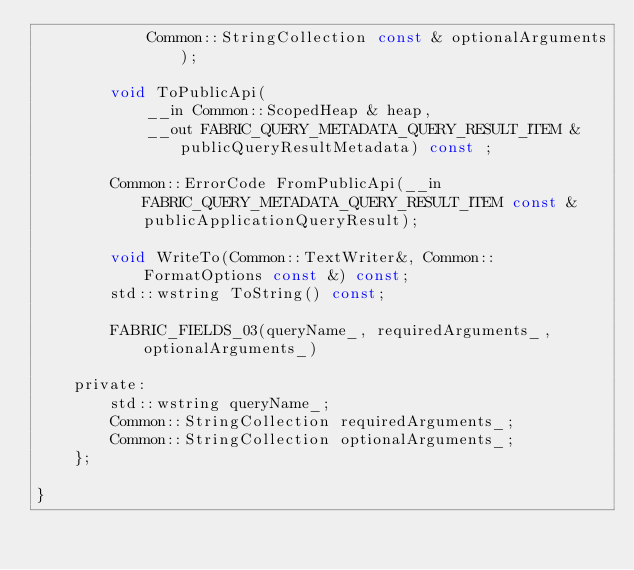<code> <loc_0><loc_0><loc_500><loc_500><_C_>            Common::StringCollection const & optionalArguments);

        void ToPublicApi(
            __in Common::ScopedHeap & heap, 
            __out FABRIC_QUERY_METADATA_QUERY_RESULT_ITEM & publicQueryResultMetadata) const ;

        Common::ErrorCode FromPublicApi(__in FABRIC_QUERY_METADATA_QUERY_RESULT_ITEM const &publicApplicationQueryResult);

        void WriteTo(Common::TextWriter&, Common::FormatOptions const &) const;
        std::wstring ToString() const;

        FABRIC_FIELDS_03(queryName_, requiredArguments_, optionalArguments_)

    private:
        std::wstring queryName_;
        Common::StringCollection requiredArguments_;
        Common::StringCollection optionalArguments_;
    };

}
</code> 